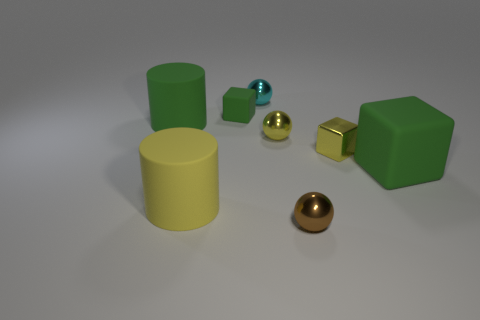There is a small object that is the same color as the tiny metal cube; what shape is it?
Make the answer very short. Sphere. How many matte cylinders have the same size as the yellow metallic ball?
Make the answer very short. 0. There is a thing in front of the big yellow matte cylinder; are there any small brown balls in front of it?
Provide a short and direct response. No. How many objects are either large brown shiny balls or tiny green rubber cubes?
Provide a succinct answer. 1. What is the color of the big cube behind the shiny sphere in front of the large matte thing that is to the right of the yellow matte cylinder?
Offer a terse response. Green. Are there any other things of the same color as the tiny shiny cube?
Your answer should be compact. Yes. Do the metallic block and the cyan object have the same size?
Provide a succinct answer. Yes. How many objects are either balls that are behind the small brown sphere or tiny blocks right of the brown object?
Provide a succinct answer. 3. What material is the large object that is in front of the green cube to the right of the small rubber thing?
Make the answer very short. Rubber. What number of other things are there of the same material as the yellow block
Your answer should be very brief. 3. 